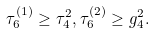Convert formula to latex. <formula><loc_0><loc_0><loc_500><loc_500>\tau _ { 6 } ^ { ( 1 ) } \geq \tau _ { 4 } ^ { 2 } , \tau _ { 6 } ^ { ( 2 ) } \geq g _ { 4 } ^ { 2 } .</formula> 